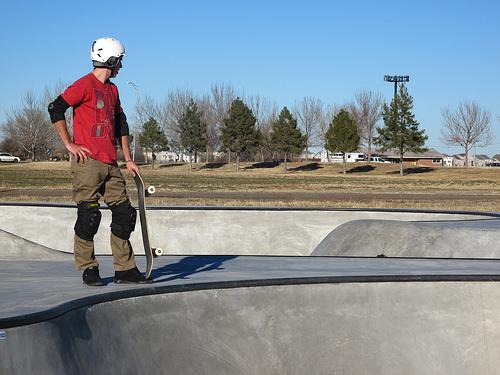Describe the skateboard held by the man in the image, including the color and a detail about the wheels. The man is holding a black skateboard with white wheels in his hand. What does the man appear to be doing, and where is he positioned in the skate park? The man is standing on top of a ramp in the skate park, holding a black skateboard with white wheels in his hand. List three protective gear items worn by the skateboarder in the image. White safety helmet, black knee pads, and black elbow pads. What kind of pants and shoes is the man wearing in the image? The man is wearing a pair of brown pants (khakis) and black shoes. What type of landscape is surrounding the person with a skateboard? Mention the weather as well. The skateboarder is surrounded by a cement skate park, green pine trees, and grassy areas under a clear blue sky. Name three objects in the background of the image, including elements of nature. Three green pine trees, a large light post, and a car parked in the distance. What is the primary setting of this image, including the weather conditions? The setting is a cement skate park with skateboarding ramp, surrounded by green pine trees under a clear blue sky during the day. Identify the primary object in the image and describe its appearance. A man wearing a red shirt, white helmet, knee pads, and elbow pads is holding a black skateboard with white wheels in his hand. Describe the general theme of the image using one sentence. A man dressed in protective gear holding a skateboard stands in a cement skate park surrounded by green trees on a sunny day. How does the skateboarder protect himself during the activity? Mention at least two items. The skateboarder is wearing a white safety helmet and black knee pads for protection. 